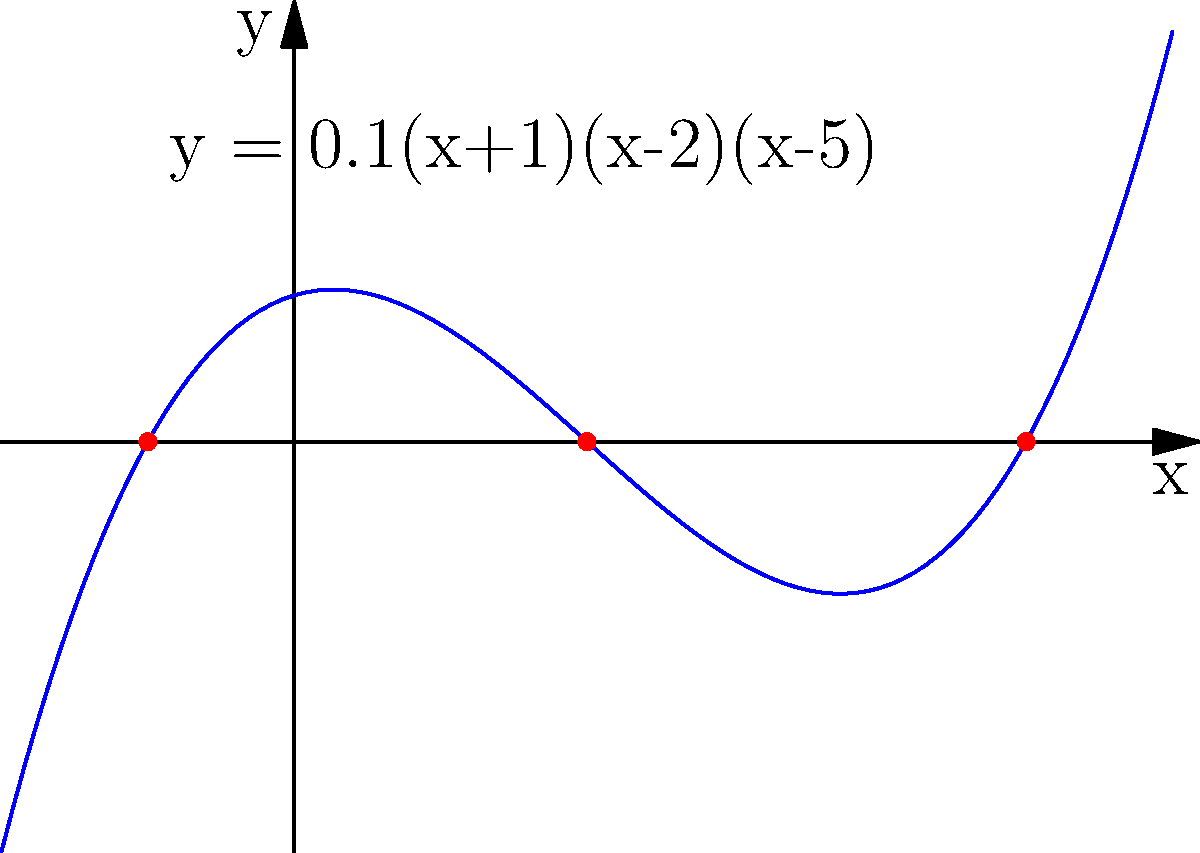As a factory supervisor, you're tasked with optimizing the maintenance schedule for a critical machine. The performance of the machine over time can be modeled by the polynomial function $y = 0.1(x+1)(x-2)(x-5)$, where $x$ represents months since the last maintenance and $y$ represents efficiency loss. Based on the graph, what is the maximum number of months you can wait between maintenance sessions while ensuring the machine doesn't enter negative efficiency (i.e., complete breakdown)? To solve this problem, we need to follow these steps:

1. Understand the function: $y = 0.1(x+1)(x-2)(x-5)$ represents the efficiency loss over time.

2. Interpret the graph: 
   - The x-axis represents months since last maintenance.
   - The y-axis represents efficiency loss.
   - The roots of the function (where y = 0) are the points where the graph crosses the x-axis.

3. Identify the roots: From the graph, we can see three roots at x = -1, 2, and 5.

4. Interpret the roots:
   - x = -1 is not relevant as we can't have negative time.
   - x = 2 represents 2 months after maintenance, where efficiency loss returns to 0.
   - x = 5 represents 5 months after maintenance, where efficiency loss again reaches 0.

5. Analyze the behavior between roots:
   - Between x = 2 and x = 5, the function dips below the x-axis, indicating negative efficiency loss (i.e., improved efficiency).
   - After x = 5, the function rises above the x-axis, indicating positive efficiency loss.

6. Determine the maximum waiting time:
   - To avoid entering negative efficiency (complete breakdown), we must perform maintenance before the function rises above the x-axis again after x = 5.
   - Therefore, the maximum number of months we can wait is 5.
Answer: 5 months 